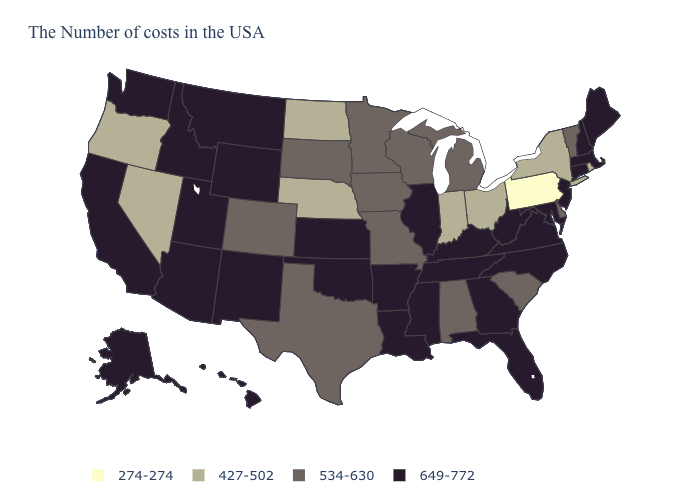Name the states that have a value in the range 534-630?
Be succinct. Vermont, Delaware, South Carolina, Michigan, Alabama, Wisconsin, Missouri, Minnesota, Iowa, Texas, South Dakota, Colorado. Does Connecticut have a higher value than New Hampshire?
Be succinct. No. What is the value of Minnesota?
Concise answer only. 534-630. Name the states that have a value in the range 649-772?
Short answer required. Maine, Massachusetts, New Hampshire, Connecticut, New Jersey, Maryland, Virginia, North Carolina, West Virginia, Florida, Georgia, Kentucky, Tennessee, Illinois, Mississippi, Louisiana, Arkansas, Kansas, Oklahoma, Wyoming, New Mexico, Utah, Montana, Arizona, Idaho, California, Washington, Alaska, Hawaii. Name the states that have a value in the range 534-630?
Be succinct. Vermont, Delaware, South Carolina, Michigan, Alabama, Wisconsin, Missouri, Minnesota, Iowa, Texas, South Dakota, Colorado. Does the map have missing data?
Give a very brief answer. No. Does the first symbol in the legend represent the smallest category?
Write a very short answer. Yes. Does Alabama have a lower value than Ohio?
Answer briefly. No. Name the states that have a value in the range 534-630?
Quick response, please. Vermont, Delaware, South Carolina, Michigan, Alabama, Wisconsin, Missouri, Minnesota, Iowa, Texas, South Dakota, Colorado. What is the highest value in the USA?
Be succinct. 649-772. Which states have the lowest value in the Northeast?
Short answer required. Pennsylvania. What is the value of Alaska?
Keep it brief. 649-772. Which states have the lowest value in the USA?
Keep it brief. Pennsylvania. Is the legend a continuous bar?
Short answer required. No. What is the value of Utah?
Write a very short answer. 649-772. 